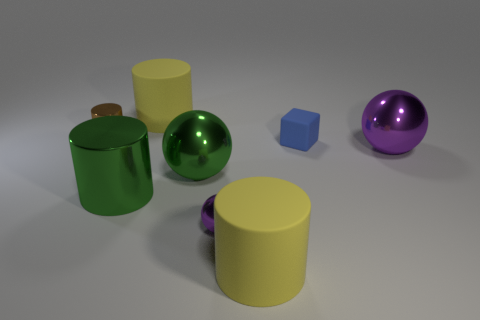There is a ball that is the same size as the brown metallic cylinder; what is it made of?
Your response must be concise. Metal. There is a large object that is right of the large green metal sphere and left of the blue block; what is its shape?
Offer a very short reply. Cylinder. What is the color of the cylinder that is the same size as the matte cube?
Keep it short and to the point. Brown. Is the size of the yellow rubber cylinder behind the tiny brown object the same as the green metal thing that is in front of the green shiny sphere?
Offer a terse response. Yes. There is a yellow object that is on the right side of the yellow matte object behind the metal thing right of the tiny purple metal object; how big is it?
Provide a short and direct response. Large. What shape is the small brown metal object to the left of the purple ball to the right of the small rubber block?
Offer a very short reply. Cylinder. Is the color of the large ball behind the green sphere the same as the large metallic cylinder?
Your answer should be compact. No. What is the color of the matte thing that is both right of the large green sphere and behind the large purple sphere?
Give a very brief answer. Blue. Is there a thing made of the same material as the green sphere?
Your response must be concise. Yes. The green sphere has what size?
Offer a very short reply. Large. 